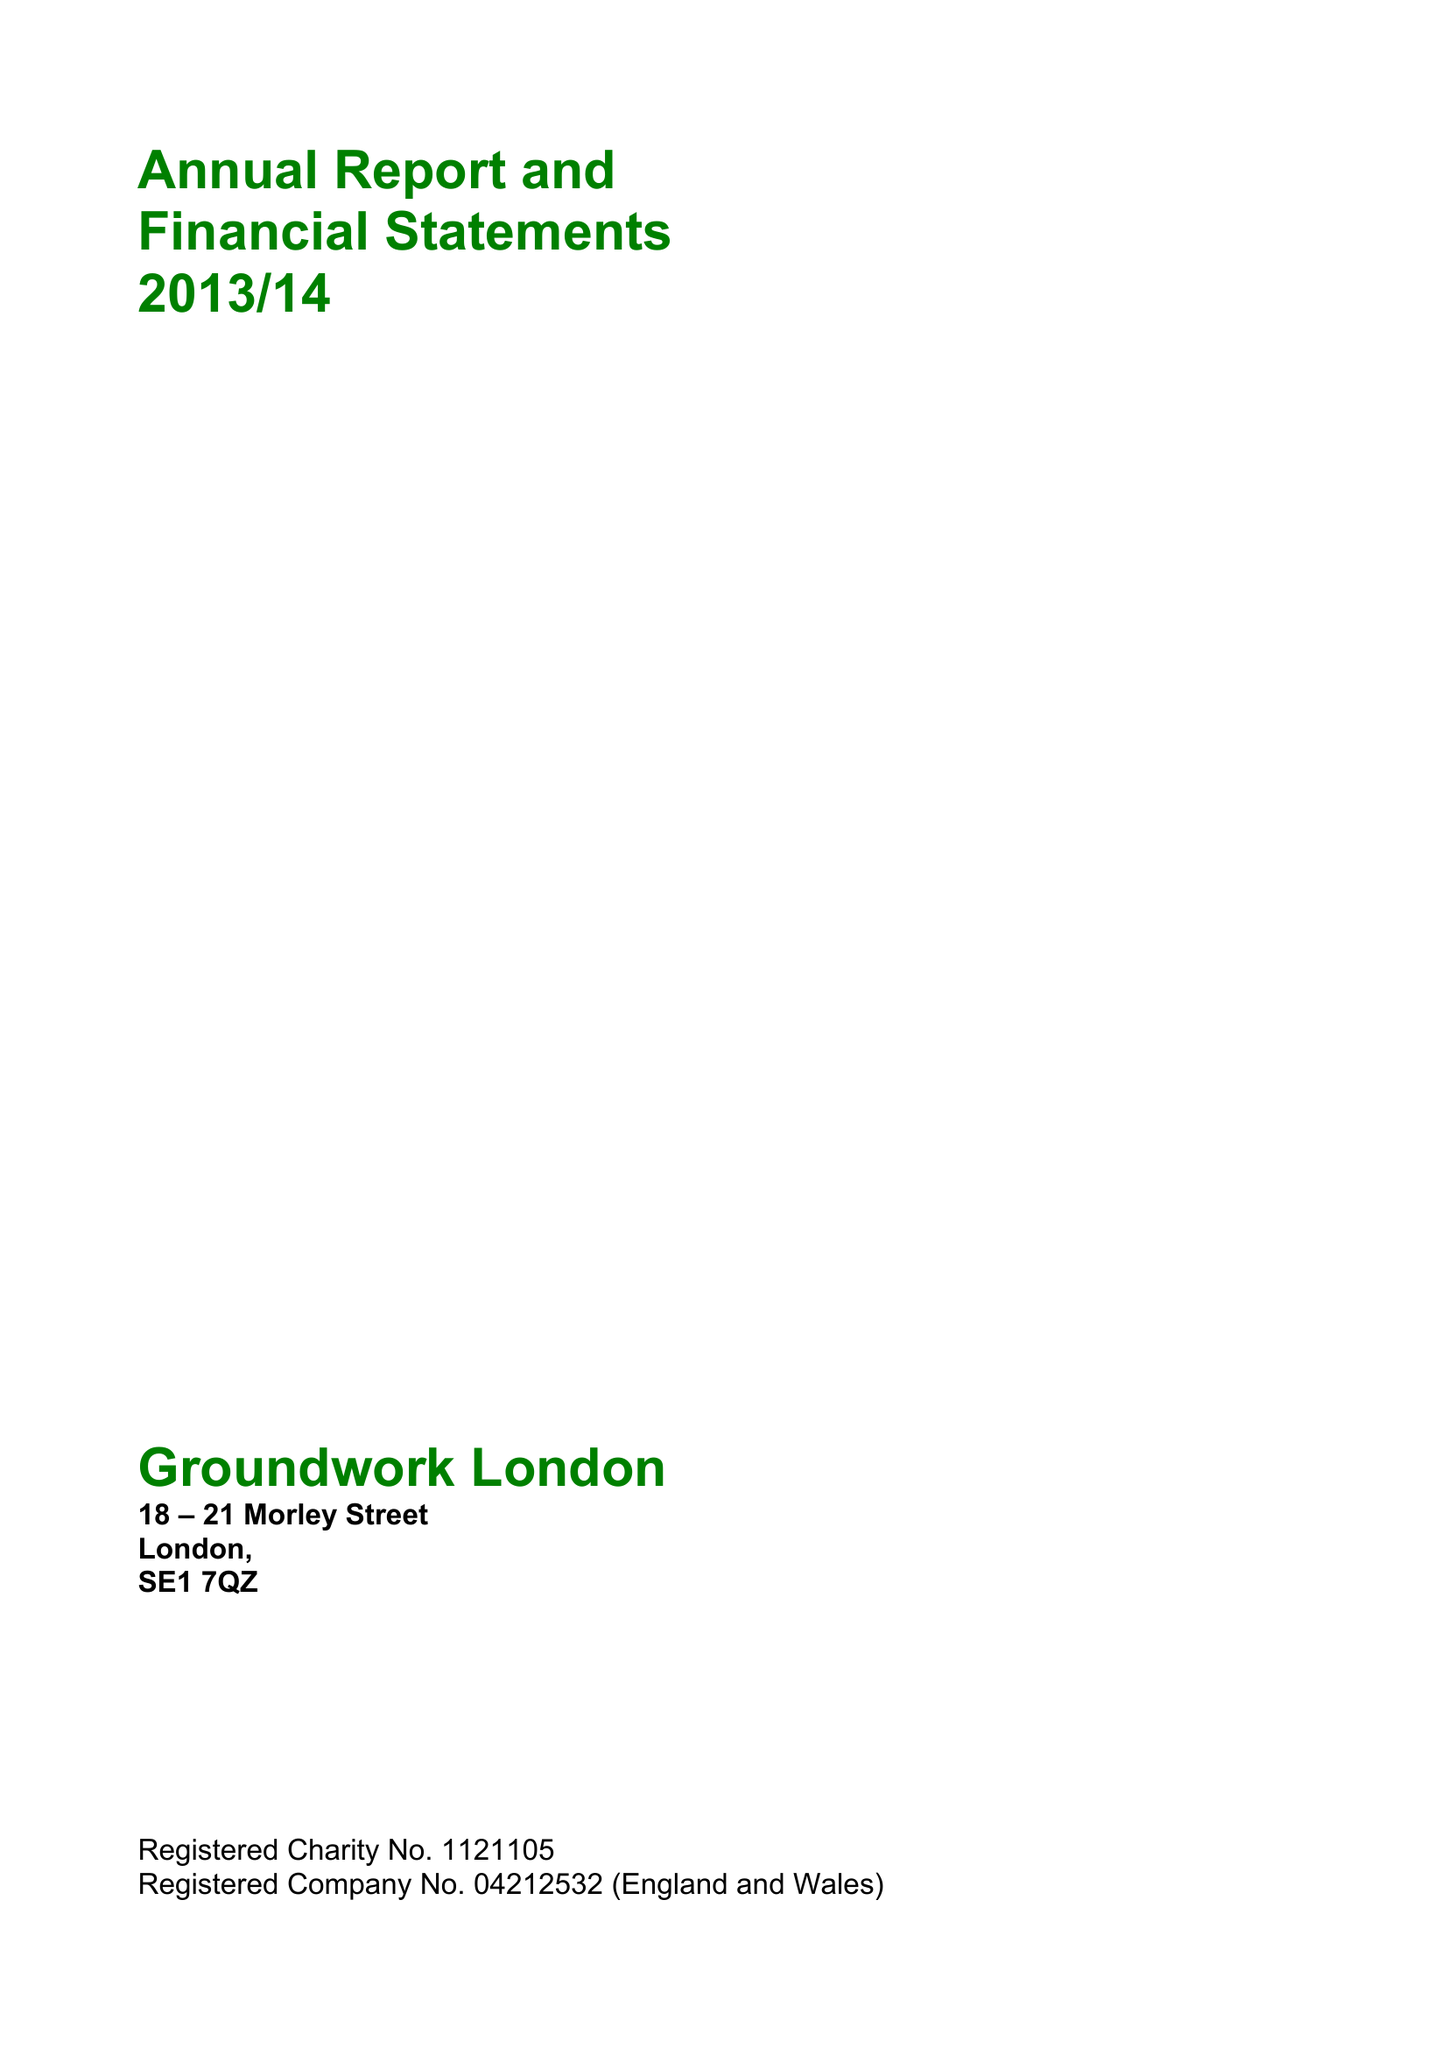What is the value for the charity_name?
Answer the question using a single word or phrase. Groundwork London 